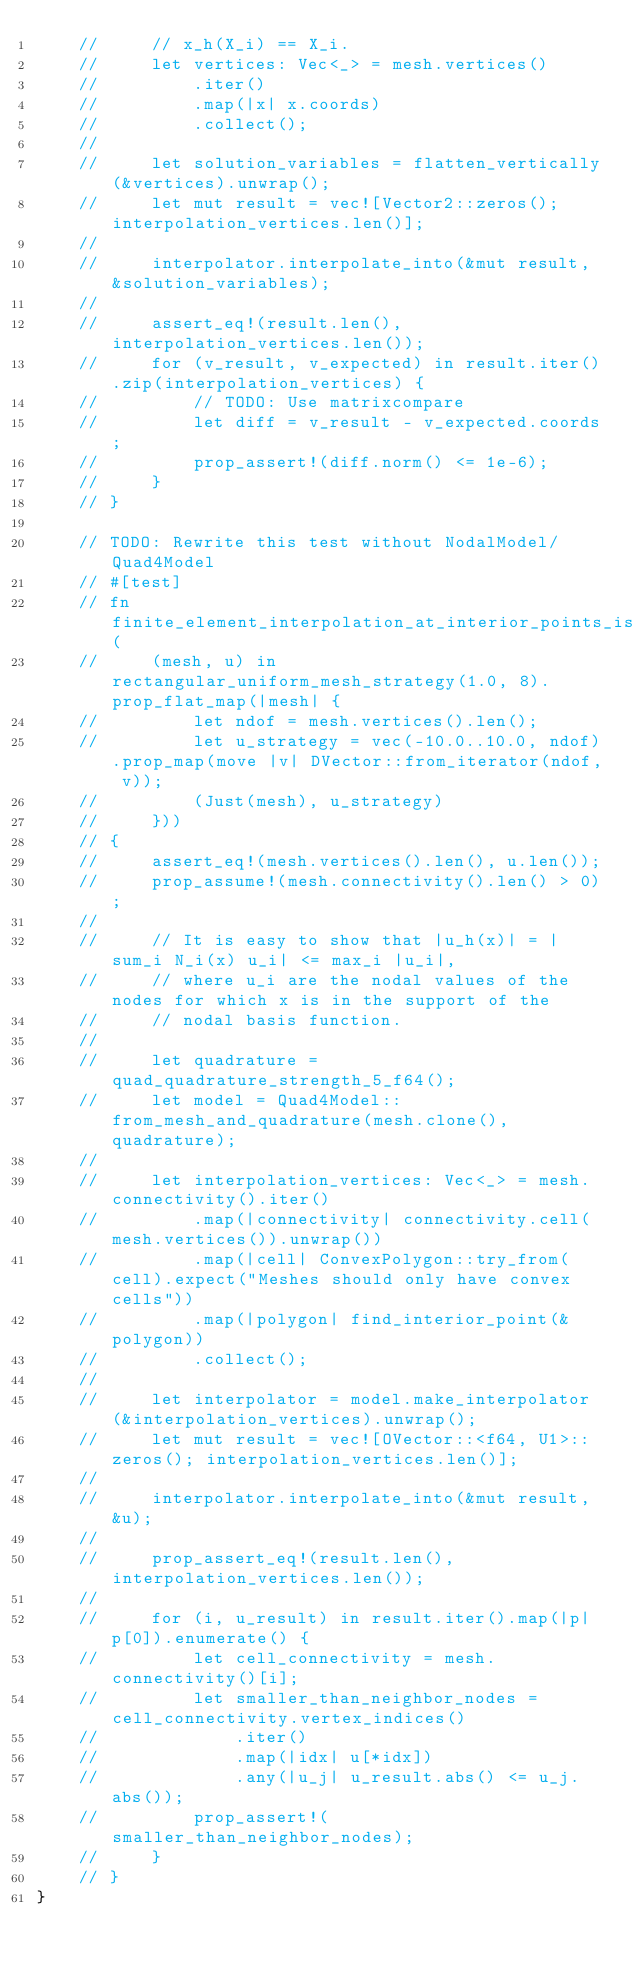<code> <loc_0><loc_0><loc_500><loc_500><_Rust_>    //     // x_h(X_i) == X_i.
    //     let vertices: Vec<_> = mesh.vertices()
    //         .iter()
    //         .map(|x| x.coords)
    //         .collect();
    //
    //     let solution_variables = flatten_vertically(&vertices).unwrap();
    //     let mut result = vec![Vector2::zeros(); interpolation_vertices.len()];
    //
    //     interpolator.interpolate_into(&mut result, &solution_variables);
    //
    //     assert_eq!(result.len(), interpolation_vertices.len());
    //     for (v_result, v_expected) in result.iter().zip(interpolation_vertices) {
    //         // TODO: Use matrixcompare
    //         let diff = v_result - v_expected.coords;
    //         prop_assert!(diff.norm() <= 1e-6);
    //     }
    // }

    // TODO: Rewrite this test without NodalModel/Quad4Model
    // #[test]
    // fn finite_element_interpolation_at_interior_points_is_bounded_by_nodal_values(
    //     (mesh, u) in rectangular_uniform_mesh_strategy(1.0, 8).prop_flat_map(|mesh| {
    //         let ndof = mesh.vertices().len();
    //         let u_strategy = vec(-10.0..10.0, ndof).prop_map(move |v| DVector::from_iterator(ndof, v));
    //         (Just(mesh), u_strategy)
    //     }))
    // {
    //     assert_eq!(mesh.vertices().len(), u.len());
    //     prop_assume!(mesh.connectivity().len() > 0);
    //
    //     // It is easy to show that |u_h(x)| = |sum_i N_i(x) u_i| <= max_i |u_i|,
    //     // where u_i are the nodal values of the nodes for which x is in the support of the
    //     // nodal basis function.
    //
    //     let quadrature = quad_quadrature_strength_5_f64();
    //     let model = Quad4Model::from_mesh_and_quadrature(mesh.clone(), quadrature);
    //
    //     let interpolation_vertices: Vec<_> = mesh.connectivity().iter()
    //         .map(|connectivity| connectivity.cell(mesh.vertices()).unwrap())
    //         .map(|cell| ConvexPolygon::try_from(cell).expect("Meshes should only have convex cells"))
    //         .map(|polygon| find_interior_point(&polygon))
    //         .collect();
    //
    //     let interpolator = model.make_interpolator(&interpolation_vertices).unwrap();
    //     let mut result = vec![OVector::<f64, U1>::zeros(); interpolation_vertices.len()];
    //
    //     interpolator.interpolate_into(&mut result, &u);
    //
    //     prop_assert_eq!(result.len(), interpolation_vertices.len());
    //
    //     for (i, u_result) in result.iter().map(|p| p[0]).enumerate() {
    //         let cell_connectivity = mesh.connectivity()[i];
    //         let smaller_than_neighbor_nodes = cell_connectivity.vertex_indices()
    //             .iter()
    //             .map(|idx| u[*idx])
    //             .any(|u_j| u_result.abs() <= u_j.abs());
    //         prop_assert!(smaller_than_neighbor_nodes);
    //     }
    // }
}
</code> 